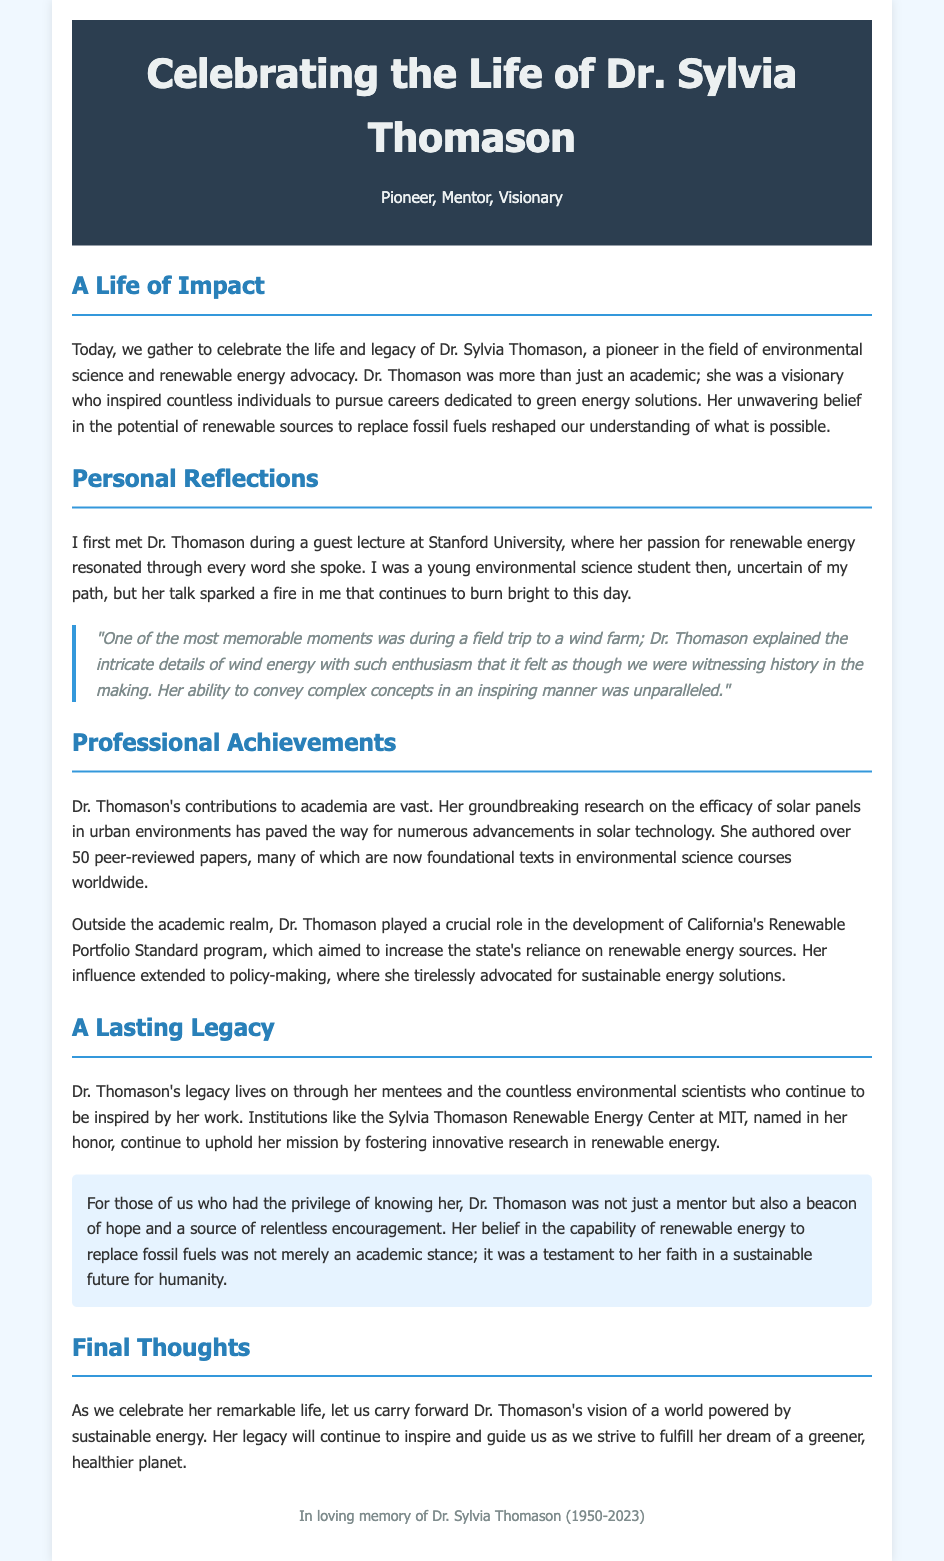What is the full name of the individual being honored? The document presents a eulogy for Dr. Sylvia Thomason, a significant figure in environmental science.
Answer: Dr. Sylvia Thomason What year was Dr. Sylvia Thomason born? The eulogy states that Dr. Thomason was born in 1950.
Answer: 1950 How many peer-reviewed papers did Dr. Thomason author? The document notes that Dr. Thomason authored over 50 peer-reviewed papers.
Answer: over 50 What was the name of the renewable energy center named in her honor? The eulogy mentions the Sylvia Thomason Renewable Energy Center at MIT.
Answer: Sylvia Thomason Renewable Energy Center at MIT What program in California did Dr. Thomason contribute to? The document highlights her role in the development of California's Renewable Portfolio Standard program.
Answer: Renewable Portfolio Standard program In what year did Dr. Sylvia Thomason pass away? The eulogy indicates that she passed away in 2023.
Answer: 2023 What did Dr. Thomason believe about renewable energy? According to the eulogy, her belief was that renewable energy could replace fossil fuels.
Answer: replace fossil fuels What emotion did Dr. Thomason's mentorship evoke in her mentees? The document describes her mentorship as a source of relentless encouragement and hope.
Answer: hope What type of energy solutions did Dr. Thomason advocate for? The eulogy states that she advocated for sustainable energy solutions.
Answer: sustainable energy solutions 